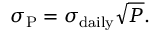Convert formula to latex. <formula><loc_0><loc_0><loc_500><loc_500>\sigma _ { P } = \sigma _ { d a i l y } { \sqrt { P } } .</formula> 